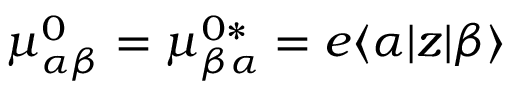Convert formula to latex. <formula><loc_0><loc_0><loc_500><loc_500>\mu _ { \alpha \beta } ^ { 0 } = \mu _ { \beta \alpha } ^ { 0 \ast } = e \langle \alpha | z | \beta \rangle</formula> 